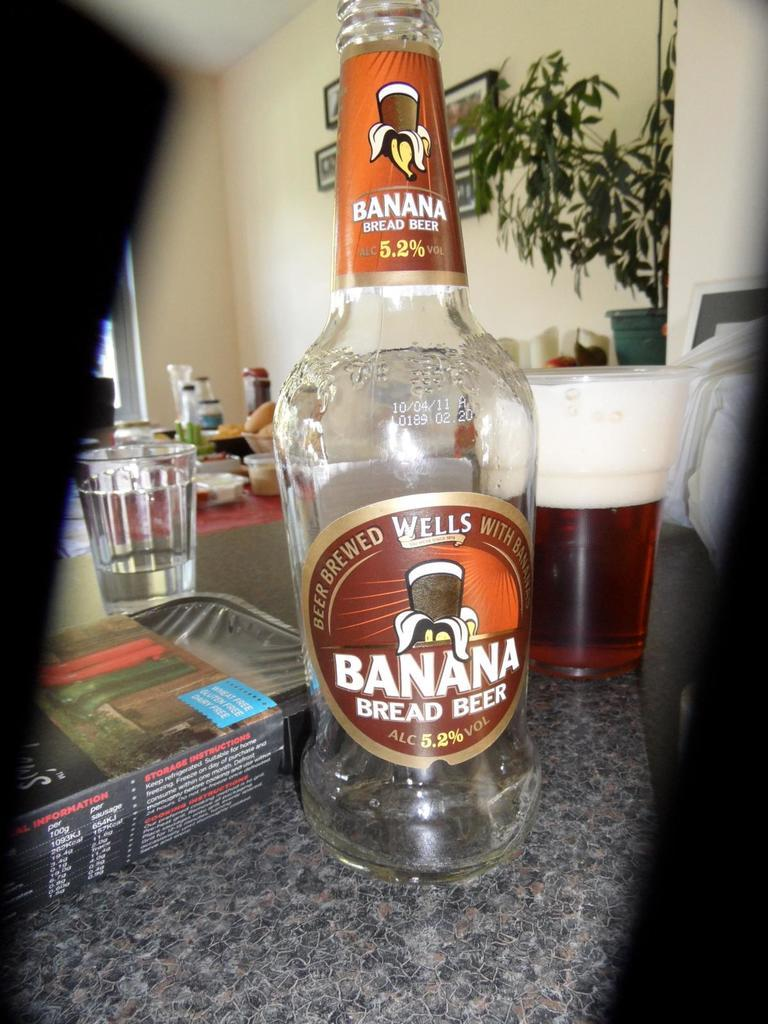Provide a one-sentence caption for the provided image. A bottle of Banana bread beer is on a counter by a tray and mug. 